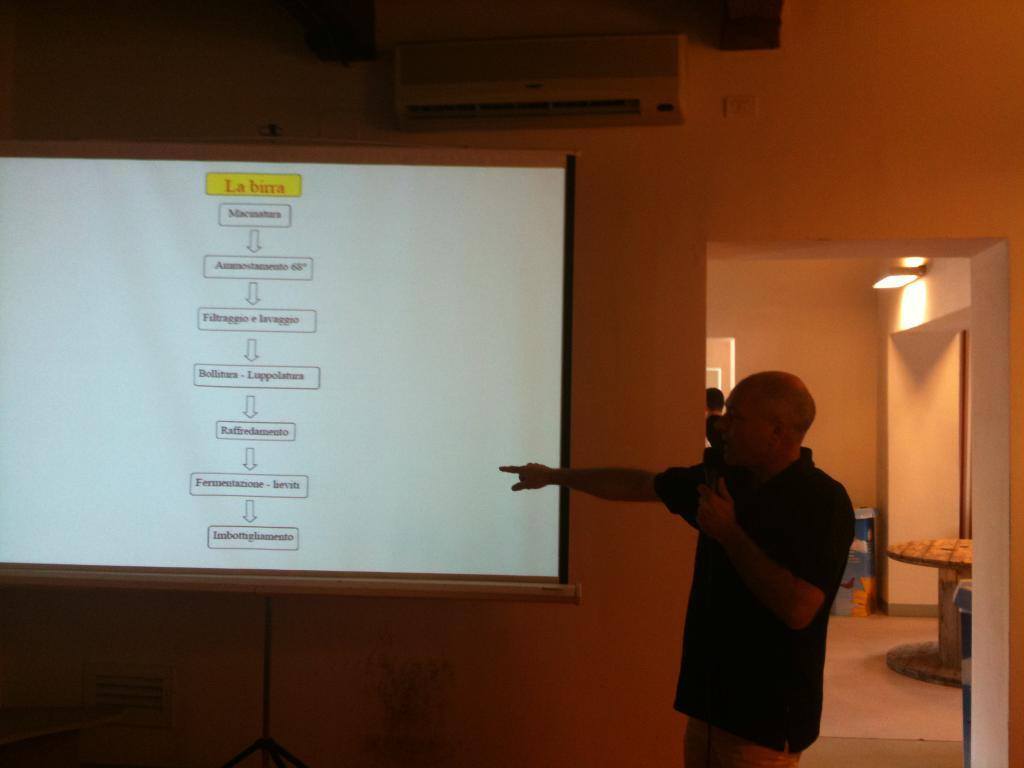<image>
Summarize the visual content of the image. La birra is the title at the beginning of the lecture slide. 